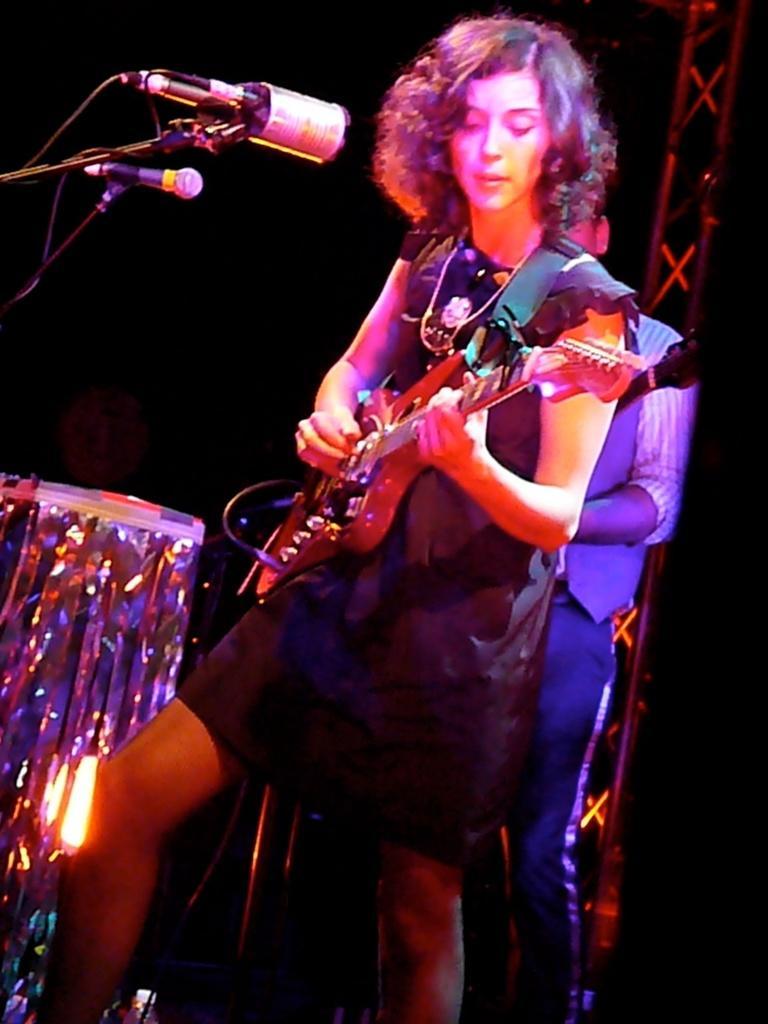Please provide a concise description of this image. In this image there is a woman standing and playing a guitar, in front of him there is a mic, behind her there is a person standing, behind the person there is a metal structure. On the left side of the image there is an object. The background is dark. 